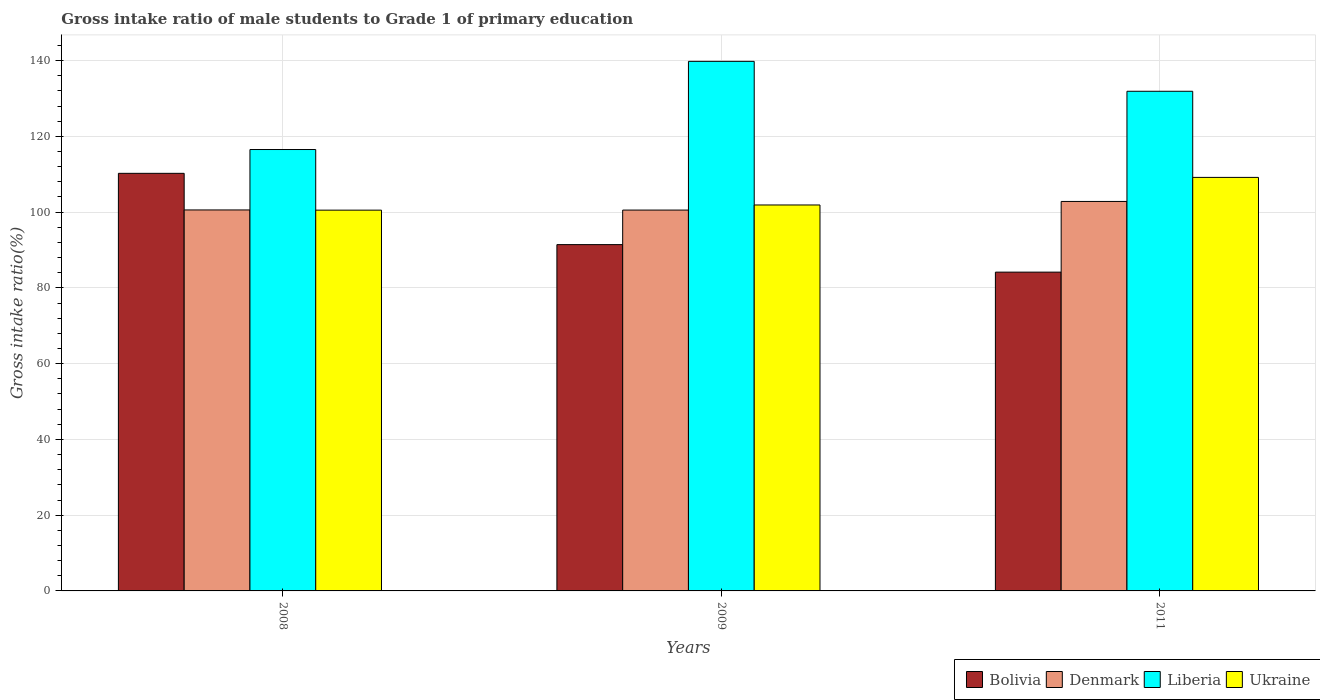How many different coloured bars are there?
Ensure brevity in your answer.  4. Are the number of bars per tick equal to the number of legend labels?
Give a very brief answer. Yes. How many bars are there on the 1st tick from the left?
Your answer should be very brief. 4. What is the gross intake ratio in Denmark in 2011?
Your answer should be very brief. 102.82. Across all years, what is the maximum gross intake ratio in Ukraine?
Provide a short and direct response. 109.17. Across all years, what is the minimum gross intake ratio in Bolivia?
Keep it short and to the point. 84.16. In which year was the gross intake ratio in Ukraine minimum?
Keep it short and to the point. 2008. What is the total gross intake ratio in Liberia in the graph?
Provide a succinct answer. 388.23. What is the difference between the gross intake ratio in Ukraine in 2009 and that in 2011?
Make the answer very short. -7.28. What is the difference between the gross intake ratio in Liberia in 2008 and the gross intake ratio in Bolivia in 2009?
Make the answer very short. 25.1. What is the average gross intake ratio in Ukraine per year?
Offer a terse response. 103.86. In the year 2011, what is the difference between the gross intake ratio in Ukraine and gross intake ratio in Bolivia?
Keep it short and to the point. 25.01. In how many years, is the gross intake ratio in Bolivia greater than 24 %?
Your response must be concise. 3. What is the ratio of the gross intake ratio in Bolivia in 2009 to that in 2011?
Your answer should be very brief. 1.09. Is the gross intake ratio in Denmark in 2008 less than that in 2009?
Keep it short and to the point. No. What is the difference between the highest and the second highest gross intake ratio in Ukraine?
Provide a short and direct response. 7.28. What is the difference between the highest and the lowest gross intake ratio in Denmark?
Give a very brief answer. 2.28. In how many years, is the gross intake ratio in Liberia greater than the average gross intake ratio in Liberia taken over all years?
Your answer should be compact. 2. What does the 4th bar from the left in 2009 represents?
Your answer should be very brief. Ukraine. What does the 1st bar from the right in 2008 represents?
Your answer should be compact. Ukraine. Is it the case that in every year, the sum of the gross intake ratio in Liberia and gross intake ratio in Bolivia is greater than the gross intake ratio in Denmark?
Make the answer very short. Yes. How many bars are there?
Make the answer very short. 12. Are all the bars in the graph horizontal?
Give a very brief answer. No. How many years are there in the graph?
Your answer should be compact. 3. What is the difference between two consecutive major ticks on the Y-axis?
Your answer should be very brief. 20. Does the graph contain grids?
Your response must be concise. Yes. How many legend labels are there?
Provide a succinct answer. 4. What is the title of the graph?
Your answer should be compact. Gross intake ratio of male students to Grade 1 of primary education. Does "Slovenia" appear as one of the legend labels in the graph?
Provide a succinct answer. No. What is the label or title of the X-axis?
Your response must be concise. Years. What is the label or title of the Y-axis?
Your answer should be compact. Gross intake ratio(%). What is the Gross intake ratio(%) in Bolivia in 2008?
Ensure brevity in your answer.  110.24. What is the Gross intake ratio(%) in Denmark in 2008?
Your response must be concise. 100.57. What is the Gross intake ratio(%) in Liberia in 2008?
Provide a short and direct response. 116.52. What is the Gross intake ratio(%) in Ukraine in 2008?
Offer a terse response. 100.52. What is the Gross intake ratio(%) in Bolivia in 2009?
Give a very brief answer. 91.42. What is the Gross intake ratio(%) of Denmark in 2009?
Make the answer very short. 100.54. What is the Gross intake ratio(%) in Liberia in 2009?
Give a very brief answer. 139.8. What is the Gross intake ratio(%) of Ukraine in 2009?
Give a very brief answer. 101.89. What is the Gross intake ratio(%) of Bolivia in 2011?
Offer a very short reply. 84.16. What is the Gross intake ratio(%) of Denmark in 2011?
Ensure brevity in your answer.  102.82. What is the Gross intake ratio(%) in Liberia in 2011?
Provide a succinct answer. 131.9. What is the Gross intake ratio(%) of Ukraine in 2011?
Your answer should be compact. 109.17. Across all years, what is the maximum Gross intake ratio(%) of Bolivia?
Provide a short and direct response. 110.24. Across all years, what is the maximum Gross intake ratio(%) of Denmark?
Offer a terse response. 102.82. Across all years, what is the maximum Gross intake ratio(%) in Liberia?
Offer a very short reply. 139.8. Across all years, what is the maximum Gross intake ratio(%) in Ukraine?
Ensure brevity in your answer.  109.17. Across all years, what is the minimum Gross intake ratio(%) of Bolivia?
Keep it short and to the point. 84.16. Across all years, what is the minimum Gross intake ratio(%) of Denmark?
Give a very brief answer. 100.54. Across all years, what is the minimum Gross intake ratio(%) in Liberia?
Offer a terse response. 116.52. Across all years, what is the minimum Gross intake ratio(%) in Ukraine?
Offer a terse response. 100.52. What is the total Gross intake ratio(%) in Bolivia in the graph?
Ensure brevity in your answer.  285.82. What is the total Gross intake ratio(%) of Denmark in the graph?
Offer a very short reply. 303.94. What is the total Gross intake ratio(%) in Liberia in the graph?
Your answer should be compact. 388.23. What is the total Gross intake ratio(%) of Ukraine in the graph?
Provide a succinct answer. 311.58. What is the difference between the Gross intake ratio(%) of Bolivia in 2008 and that in 2009?
Provide a short and direct response. 18.82. What is the difference between the Gross intake ratio(%) of Denmark in 2008 and that in 2009?
Your answer should be very brief. 0.03. What is the difference between the Gross intake ratio(%) in Liberia in 2008 and that in 2009?
Provide a short and direct response. -23.28. What is the difference between the Gross intake ratio(%) in Ukraine in 2008 and that in 2009?
Make the answer very short. -1.36. What is the difference between the Gross intake ratio(%) in Bolivia in 2008 and that in 2011?
Provide a short and direct response. 26.08. What is the difference between the Gross intake ratio(%) of Denmark in 2008 and that in 2011?
Offer a very short reply. -2.25. What is the difference between the Gross intake ratio(%) of Liberia in 2008 and that in 2011?
Your response must be concise. -15.38. What is the difference between the Gross intake ratio(%) in Ukraine in 2008 and that in 2011?
Offer a very short reply. -8.64. What is the difference between the Gross intake ratio(%) in Bolivia in 2009 and that in 2011?
Your response must be concise. 7.27. What is the difference between the Gross intake ratio(%) of Denmark in 2009 and that in 2011?
Your answer should be compact. -2.28. What is the difference between the Gross intake ratio(%) in Liberia in 2009 and that in 2011?
Your answer should be compact. 7.9. What is the difference between the Gross intake ratio(%) of Ukraine in 2009 and that in 2011?
Offer a very short reply. -7.28. What is the difference between the Gross intake ratio(%) in Bolivia in 2008 and the Gross intake ratio(%) in Denmark in 2009?
Keep it short and to the point. 9.7. What is the difference between the Gross intake ratio(%) of Bolivia in 2008 and the Gross intake ratio(%) of Liberia in 2009?
Ensure brevity in your answer.  -29.56. What is the difference between the Gross intake ratio(%) in Bolivia in 2008 and the Gross intake ratio(%) in Ukraine in 2009?
Give a very brief answer. 8.35. What is the difference between the Gross intake ratio(%) in Denmark in 2008 and the Gross intake ratio(%) in Liberia in 2009?
Ensure brevity in your answer.  -39.23. What is the difference between the Gross intake ratio(%) of Denmark in 2008 and the Gross intake ratio(%) of Ukraine in 2009?
Provide a short and direct response. -1.31. What is the difference between the Gross intake ratio(%) in Liberia in 2008 and the Gross intake ratio(%) in Ukraine in 2009?
Make the answer very short. 14.64. What is the difference between the Gross intake ratio(%) in Bolivia in 2008 and the Gross intake ratio(%) in Denmark in 2011?
Offer a very short reply. 7.42. What is the difference between the Gross intake ratio(%) in Bolivia in 2008 and the Gross intake ratio(%) in Liberia in 2011?
Your answer should be very brief. -21.66. What is the difference between the Gross intake ratio(%) of Bolivia in 2008 and the Gross intake ratio(%) of Ukraine in 2011?
Offer a very short reply. 1.07. What is the difference between the Gross intake ratio(%) in Denmark in 2008 and the Gross intake ratio(%) in Liberia in 2011?
Your response must be concise. -31.33. What is the difference between the Gross intake ratio(%) of Denmark in 2008 and the Gross intake ratio(%) of Ukraine in 2011?
Keep it short and to the point. -8.59. What is the difference between the Gross intake ratio(%) of Liberia in 2008 and the Gross intake ratio(%) of Ukraine in 2011?
Give a very brief answer. 7.36. What is the difference between the Gross intake ratio(%) in Bolivia in 2009 and the Gross intake ratio(%) in Denmark in 2011?
Provide a succinct answer. -11.4. What is the difference between the Gross intake ratio(%) in Bolivia in 2009 and the Gross intake ratio(%) in Liberia in 2011?
Offer a terse response. -40.48. What is the difference between the Gross intake ratio(%) in Bolivia in 2009 and the Gross intake ratio(%) in Ukraine in 2011?
Provide a succinct answer. -17.74. What is the difference between the Gross intake ratio(%) of Denmark in 2009 and the Gross intake ratio(%) of Liberia in 2011?
Keep it short and to the point. -31.36. What is the difference between the Gross intake ratio(%) of Denmark in 2009 and the Gross intake ratio(%) of Ukraine in 2011?
Offer a very short reply. -8.63. What is the difference between the Gross intake ratio(%) of Liberia in 2009 and the Gross intake ratio(%) of Ukraine in 2011?
Ensure brevity in your answer.  30.63. What is the average Gross intake ratio(%) of Bolivia per year?
Make the answer very short. 95.27. What is the average Gross intake ratio(%) in Denmark per year?
Your answer should be compact. 101.31. What is the average Gross intake ratio(%) of Liberia per year?
Your answer should be very brief. 129.41. What is the average Gross intake ratio(%) of Ukraine per year?
Provide a short and direct response. 103.86. In the year 2008, what is the difference between the Gross intake ratio(%) of Bolivia and Gross intake ratio(%) of Denmark?
Make the answer very short. 9.67. In the year 2008, what is the difference between the Gross intake ratio(%) in Bolivia and Gross intake ratio(%) in Liberia?
Offer a terse response. -6.28. In the year 2008, what is the difference between the Gross intake ratio(%) in Bolivia and Gross intake ratio(%) in Ukraine?
Keep it short and to the point. 9.72. In the year 2008, what is the difference between the Gross intake ratio(%) of Denmark and Gross intake ratio(%) of Liberia?
Your response must be concise. -15.95. In the year 2008, what is the difference between the Gross intake ratio(%) in Denmark and Gross intake ratio(%) in Ukraine?
Provide a succinct answer. 0.05. In the year 2008, what is the difference between the Gross intake ratio(%) in Liberia and Gross intake ratio(%) in Ukraine?
Keep it short and to the point. 16. In the year 2009, what is the difference between the Gross intake ratio(%) of Bolivia and Gross intake ratio(%) of Denmark?
Provide a short and direct response. -9.12. In the year 2009, what is the difference between the Gross intake ratio(%) of Bolivia and Gross intake ratio(%) of Liberia?
Ensure brevity in your answer.  -48.38. In the year 2009, what is the difference between the Gross intake ratio(%) in Bolivia and Gross intake ratio(%) in Ukraine?
Make the answer very short. -10.46. In the year 2009, what is the difference between the Gross intake ratio(%) in Denmark and Gross intake ratio(%) in Liberia?
Your response must be concise. -39.26. In the year 2009, what is the difference between the Gross intake ratio(%) of Denmark and Gross intake ratio(%) of Ukraine?
Your answer should be compact. -1.35. In the year 2009, what is the difference between the Gross intake ratio(%) in Liberia and Gross intake ratio(%) in Ukraine?
Make the answer very short. 37.91. In the year 2011, what is the difference between the Gross intake ratio(%) of Bolivia and Gross intake ratio(%) of Denmark?
Provide a short and direct response. -18.66. In the year 2011, what is the difference between the Gross intake ratio(%) in Bolivia and Gross intake ratio(%) in Liberia?
Your response must be concise. -47.74. In the year 2011, what is the difference between the Gross intake ratio(%) of Bolivia and Gross intake ratio(%) of Ukraine?
Ensure brevity in your answer.  -25.01. In the year 2011, what is the difference between the Gross intake ratio(%) in Denmark and Gross intake ratio(%) in Liberia?
Your response must be concise. -29.08. In the year 2011, what is the difference between the Gross intake ratio(%) of Denmark and Gross intake ratio(%) of Ukraine?
Keep it short and to the point. -6.35. In the year 2011, what is the difference between the Gross intake ratio(%) of Liberia and Gross intake ratio(%) of Ukraine?
Make the answer very short. 22.73. What is the ratio of the Gross intake ratio(%) of Bolivia in 2008 to that in 2009?
Offer a very short reply. 1.21. What is the ratio of the Gross intake ratio(%) in Liberia in 2008 to that in 2009?
Keep it short and to the point. 0.83. What is the ratio of the Gross intake ratio(%) in Ukraine in 2008 to that in 2009?
Offer a very short reply. 0.99. What is the ratio of the Gross intake ratio(%) of Bolivia in 2008 to that in 2011?
Your response must be concise. 1.31. What is the ratio of the Gross intake ratio(%) in Denmark in 2008 to that in 2011?
Provide a succinct answer. 0.98. What is the ratio of the Gross intake ratio(%) of Liberia in 2008 to that in 2011?
Your answer should be compact. 0.88. What is the ratio of the Gross intake ratio(%) in Ukraine in 2008 to that in 2011?
Your answer should be very brief. 0.92. What is the ratio of the Gross intake ratio(%) of Bolivia in 2009 to that in 2011?
Ensure brevity in your answer.  1.09. What is the ratio of the Gross intake ratio(%) in Denmark in 2009 to that in 2011?
Offer a very short reply. 0.98. What is the ratio of the Gross intake ratio(%) in Liberia in 2009 to that in 2011?
Your response must be concise. 1.06. What is the difference between the highest and the second highest Gross intake ratio(%) in Bolivia?
Ensure brevity in your answer.  18.82. What is the difference between the highest and the second highest Gross intake ratio(%) of Denmark?
Provide a succinct answer. 2.25. What is the difference between the highest and the second highest Gross intake ratio(%) of Liberia?
Offer a terse response. 7.9. What is the difference between the highest and the second highest Gross intake ratio(%) of Ukraine?
Make the answer very short. 7.28. What is the difference between the highest and the lowest Gross intake ratio(%) in Bolivia?
Offer a very short reply. 26.08. What is the difference between the highest and the lowest Gross intake ratio(%) of Denmark?
Keep it short and to the point. 2.28. What is the difference between the highest and the lowest Gross intake ratio(%) of Liberia?
Your answer should be compact. 23.28. What is the difference between the highest and the lowest Gross intake ratio(%) of Ukraine?
Offer a very short reply. 8.64. 